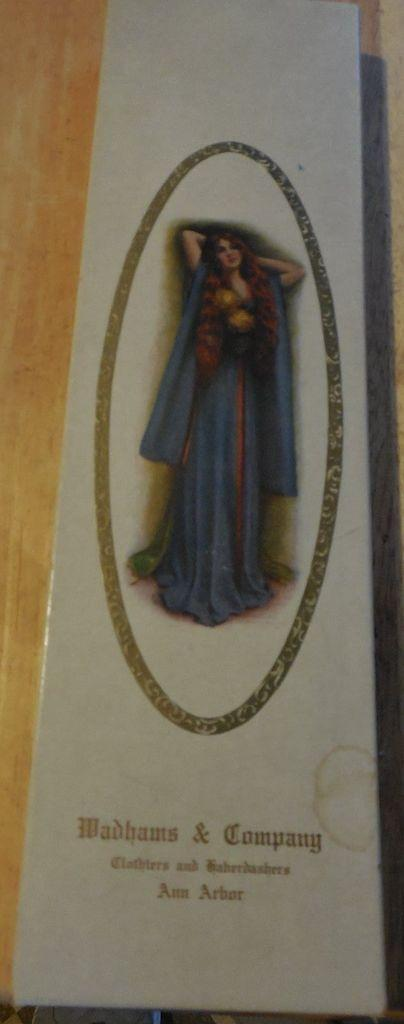What is attached to the wall in the image? There is a poster in the image that is sticked to a wall. What is depicted on the poster? The poster features a woman. Is there any text on the poster? Yes, there is text at the bottom of the poster. What type of lead can be seen being used by the woman in the poster? There is no lead or any indication of the woman using a lead in the poster. 